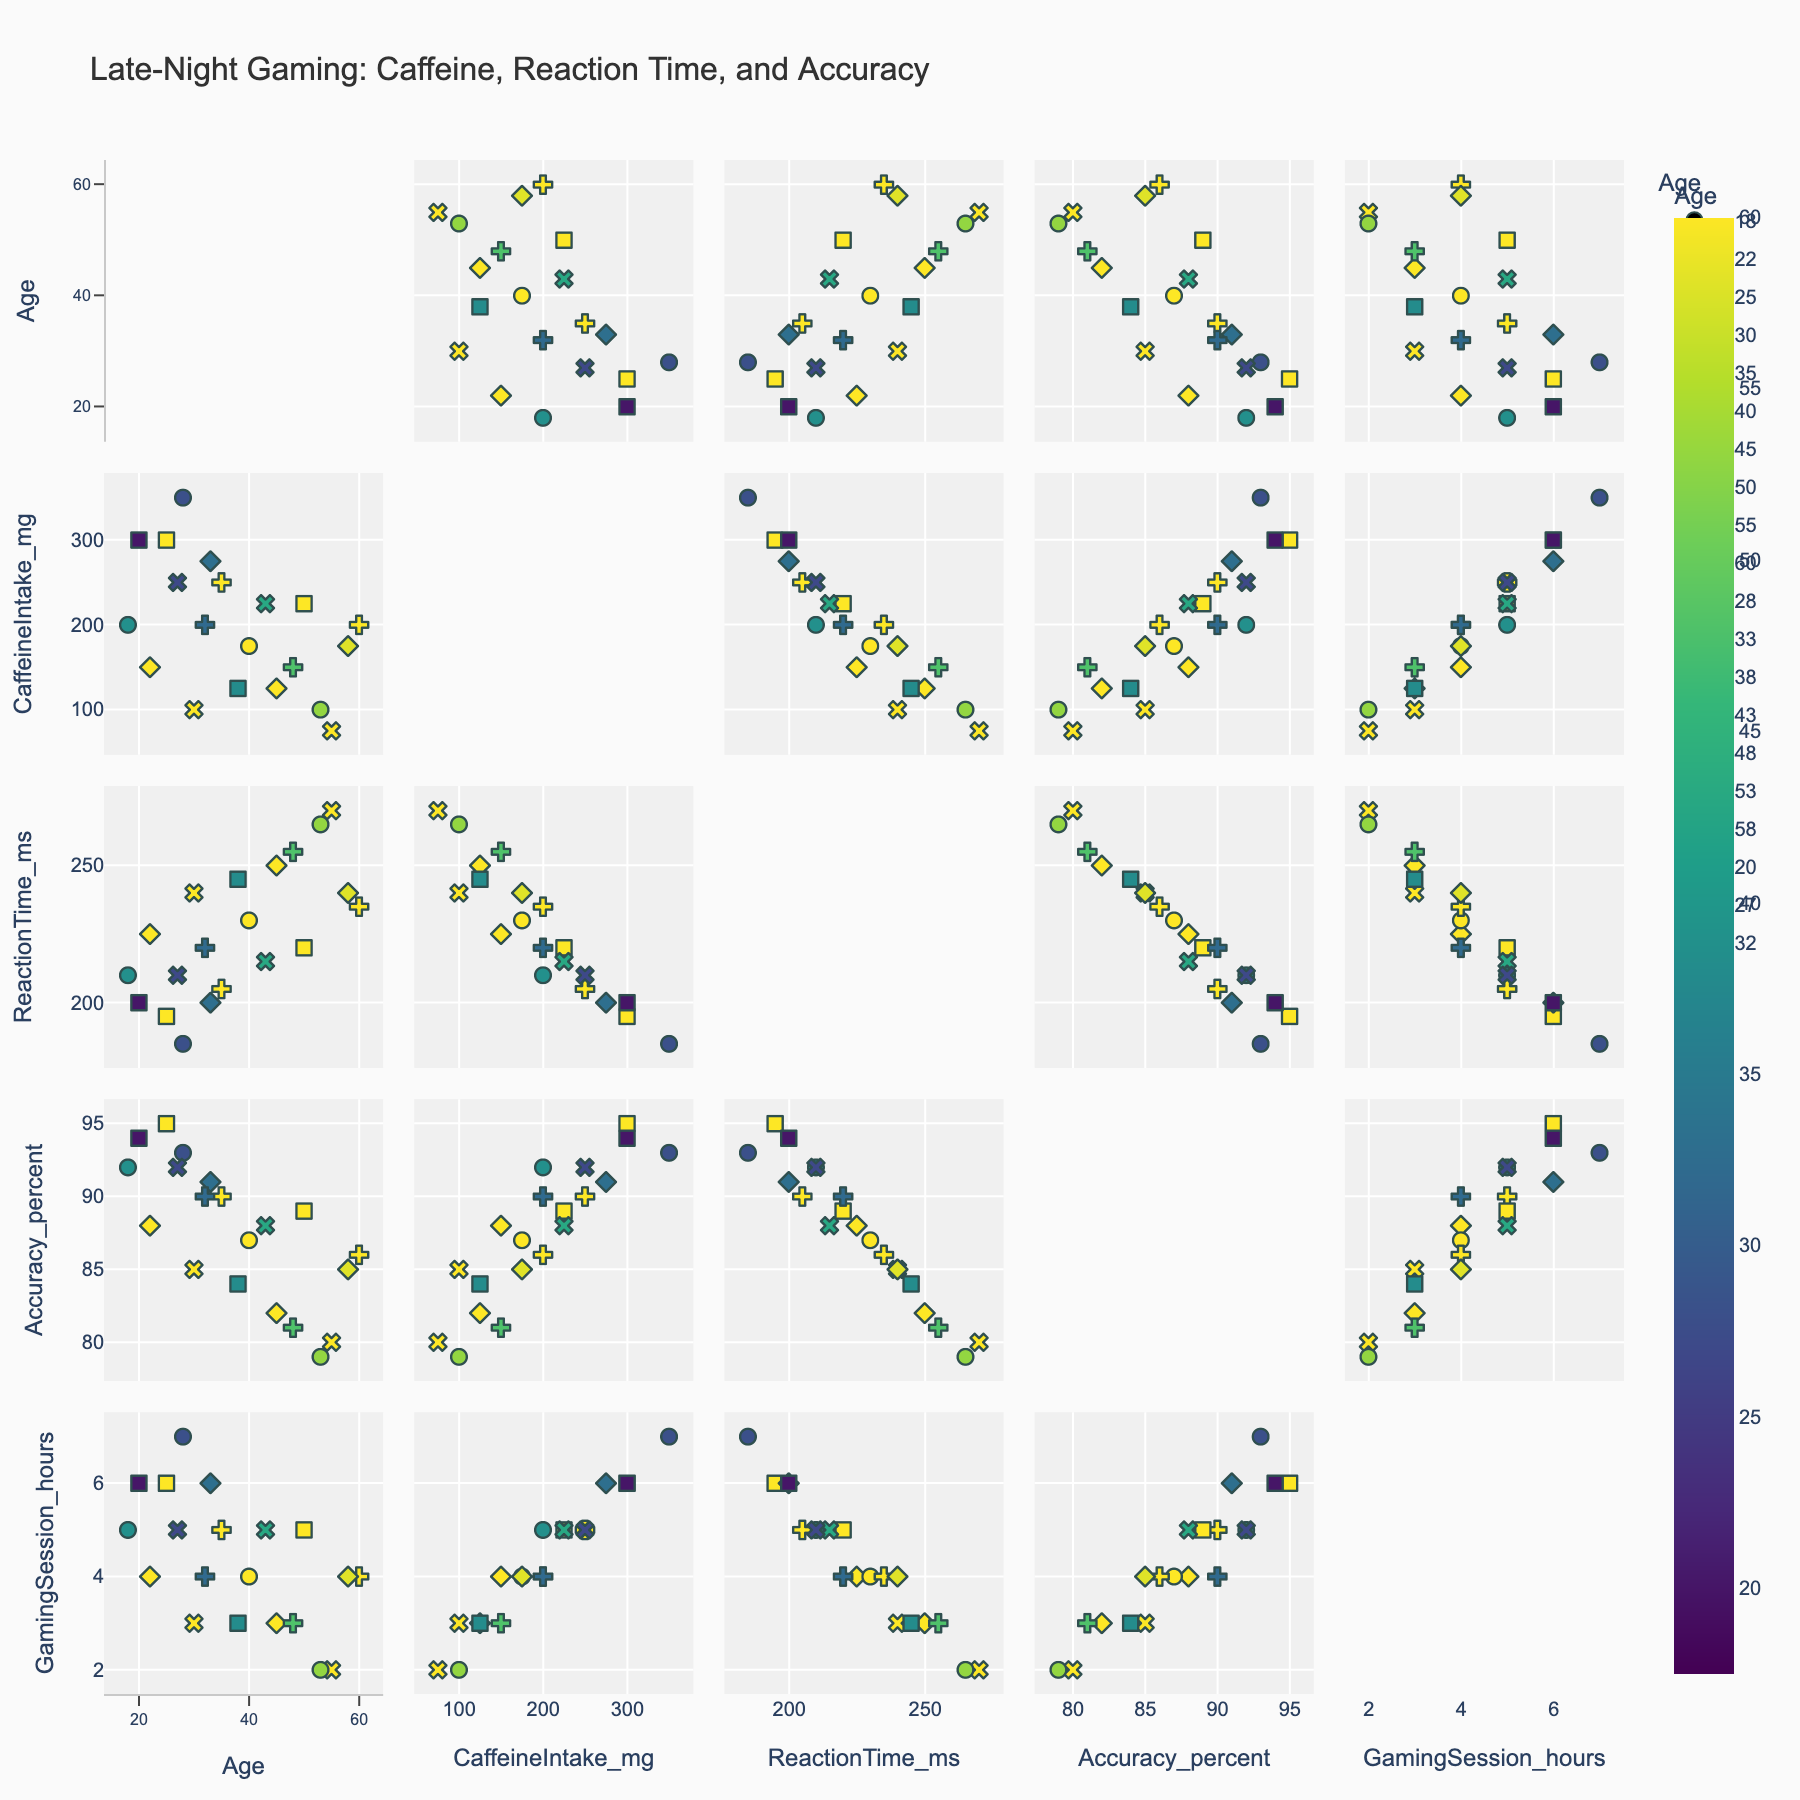What is the title of the scatterplot matrix? The title is shown at the top of the scatterplot matrix, usually in larger font to make it stand out from other elements.
Answer: Late-Night Gaming: Caffeine, Reaction Time, and Accuracy How many data points are represented for the age group 35? Look for the points color-coded or symbol-coded specifically for the age group 35 and count them.
Answer: 1 Which data points have the highest caffeine intake? Look for the point in the 'CaffeineIntake_mg' dimension that is furthest to the right (highest value).
Answer: Age 27 and Age 28 (both 350 mg) Is there an observable trend between caffeine intake and reaction time? Check the scatter plots with 'CaffeineIntake_mg' on one axis and 'ReactionTime_ms' on the other to see if there's a visible correlation, either positive or negative.
Answer: Generally negative trend Which age group tends to have the highest gaming accuracy? Observe the distribution of the 'Accuracy_percent' values for different age groups and identify which age group has the highest values.
Answer: Age 25 What is the average reaction time across all age groups? Sum all the reaction time values and divide by the number of data points to find the average reaction time. Detailed steps: Sum of all reaction times is 3990 ms, divided by 20 data points gives the average.
Answer: 199.5 ms Compare the gaming session hours of age groups 18 and 60. Which has more average gaming session hours? Look at the 'GamingSession_hours' values for age groups 18 and 60, and compare them directly.
Answer: Age 18 (5 hours vs. 4 hours) Do younger gamers (below 30) have better accuracy compared to older gamers (above 30)? Separate the data points into two groups (below 30 and above 30), compare the accuracy values and deduce which group generally performs better.
Answer: Younger gamers typically have better accuracy What is the relationship between reaction time and accuracy for the age group 50? Look at the scatter plot involving 'ReactionTime_ms' and 'Accuracy_percent' for the points specific to age group 50 and analyze their placement.
Answer: As reaction time increases, accuracy tends to decrease Which variable appears to have the strongest visual correlation with accuracy percentage? Look at the scatterplot matrix and observe the tightness and direction of clustering between 'Accuracy_percent' and other variables to determine the strongest correlation.
Answer: CaffeineIntake_mg 